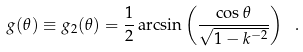Convert formula to latex. <formula><loc_0><loc_0><loc_500><loc_500>g ( \theta ) \equiv g _ { 2 } ( \theta ) = \frac { 1 } { 2 } \arcsin \left ( \frac { \cos \theta } { \sqrt { 1 - k ^ { - 2 } } } \right ) \ .</formula> 